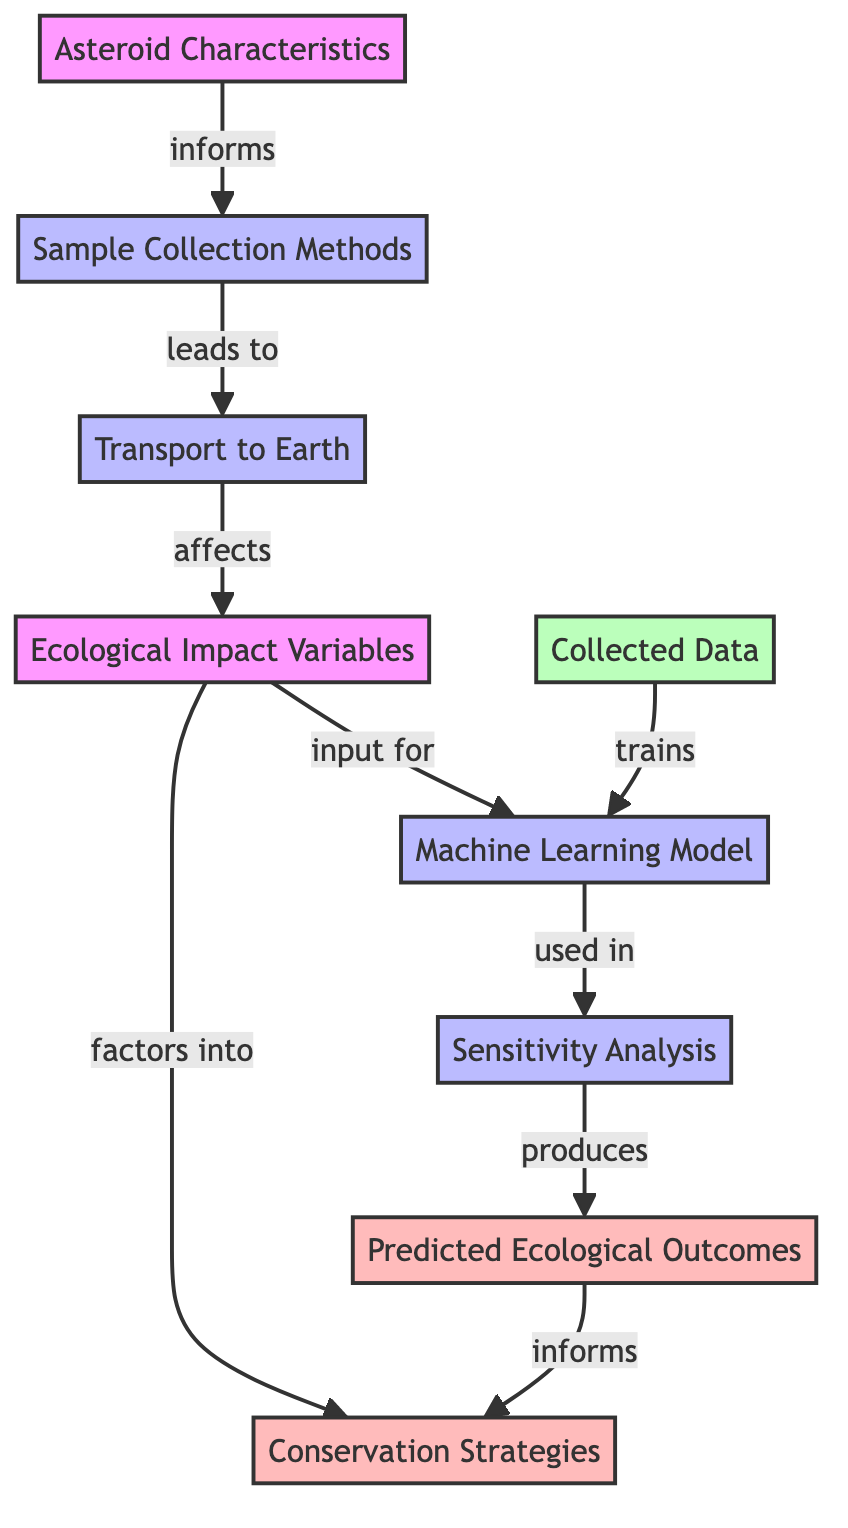What is the first node in the diagram? The first node is "Asteroid Characteristics," which represents a key input for the entire process outlined in the diagram.
Answer: Asteroid Characteristics How many processes are shown in the diagram? There are four processes depicted in the diagram: Sample Collection Methods, Transport to Earth, Machine Learning Model, and Sensitivity Analysis.
Answer: Four What does the "Ecological Impact Variables" node affect? The "Ecological Impact Variables" node affects the "Predicted Ecological Outcomes" node, indicating that these variables are crucial for the predictions made by the model.
Answer: Predicted Ecological Outcomes Which node informs the "Sensitivity Analysis"? The "Machine Learning Model" node produces outputs that are utilized in the "Sensitivity Analysis," indicating its dependence on the model's structure and outputs.
Answer: Machine Learning Model How does the "Collected Data" contribute to the process? The "Collected Data" node trains the "Machine Learning Model," providing necessary information for the model to learn and make predictions about ecological impacts.
Answer: Trains What is the final output of the diagram? The final output of the diagram is the "Conservation Strategies," which are informed by both the predicted ecological outcomes and the ecological impact variables.
Answer: Conservation Strategies Explain how "Sample Collection Methods" leads to ecological impact variables. The "Sample Collection Methods" node leads to "Transport to Earth," which subsequently affects the "Ecological Impact Variables." Thus, the method of collection directly influences the variables considered for ecological impact.
Answer: Affects What type of models is used to predict ecological outcomes? The diagram indicates that a "Machine Learning Model" is employed to predict ecological outcomes based on various input factors, such as ecological impact variables and collected data.
Answer: Machine Learning Model 